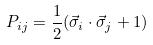Convert formula to latex. <formula><loc_0><loc_0><loc_500><loc_500>P _ { i j } = \frac { 1 } { 2 } ( \vec { \sigma } _ { i } \cdot \vec { \sigma } _ { j } + 1 )</formula> 